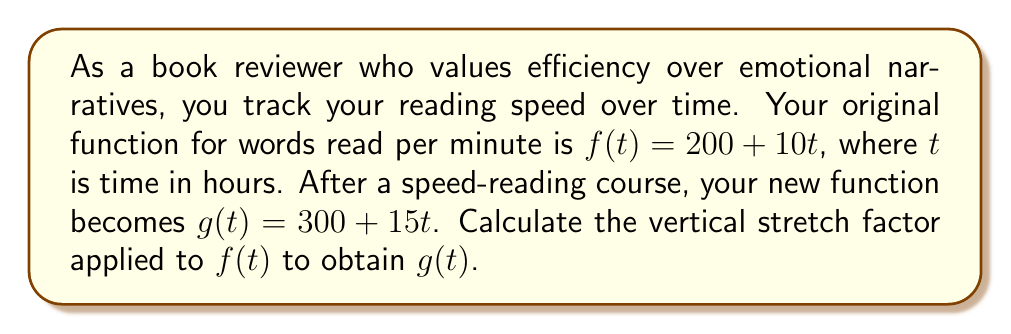Help me with this question. To find the vertical stretch factor, we need to compare the two functions:

1) Original function: $f(t) = 200 + 10t$
2) New function: $g(t) = 300 + 15t$

A vertical stretch is represented by multiplying the entire function by a constant $k$:

$g(t) = k \cdot f(t)$

Let's break this down:

3) $300 + 15t = k(200 + 10t)$
4) $300 + 15t = 200k + 10kt$

For this to be true for all $t$, the coefficients must be equal:

5) $15 = 10k$
6) $k = \frac{15}{10} = 1.5$

We can verify this with the constant term:

7) $300 = 200k = 200 \cdot 1.5 = 300$

Therefore, the vertical stretch factor is 1.5.
Answer: 1.5 